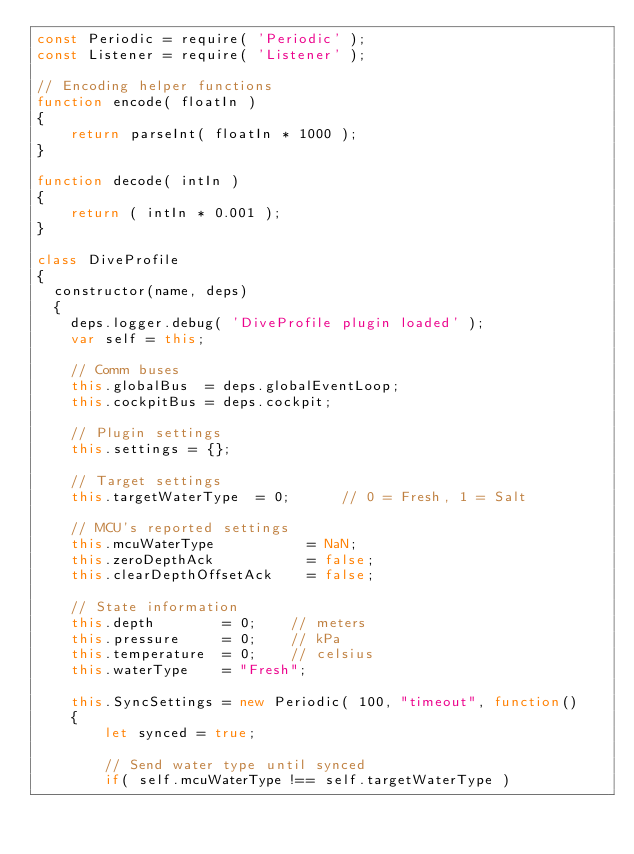<code> <loc_0><loc_0><loc_500><loc_500><_JavaScript_>const Periodic = require( 'Periodic' );
const Listener = require( 'Listener' );

// Encoding helper functions
function encode( floatIn )
{
    return parseInt( floatIn * 1000 );
}

function decode( intIn )
{
    return ( intIn * 0.001 );
}

class DiveProfile
{
  constructor(name, deps) 
  {
    deps.logger.debug( 'DiveProfile plugin loaded' );
    var self = this;

    // Comm buses
    this.globalBus  = deps.globalEventLoop;
    this.cockpitBus = deps.cockpit;

    // Plugin settings
    this.settings = {};

    // Target settings
    this.targetWaterType  = 0;      // 0 = Fresh, 1 = Salt

    // MCU's reported settings
    this.mcuWaterType           = NaN;
    this.zeroDepthAck           = false;
    this.clearDepthOffsetAck    = false;

    // State information
    this.depth        = 0;    // meters
    this.pressure     = 0;    // kPa
    this.temperature  = 0;    // celsius
    this.waterType    = "Fresh";

    this.SyncSettings = new Periodic( 100, "timeout", function()
    {
        let synced = true;

        // Send water type until synced
        if( self.mcuWaterType !== self.targetWaterType )</code> 